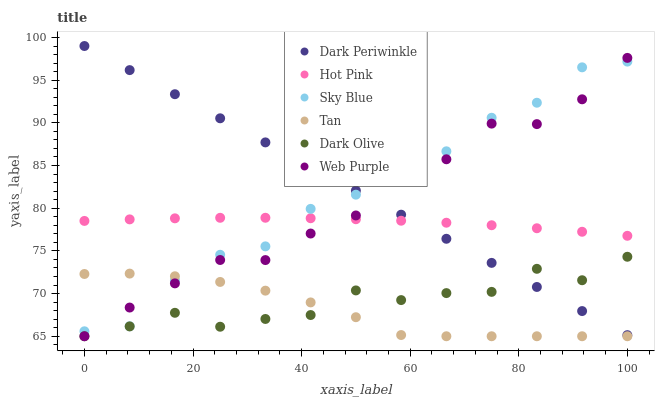Does Tan have the minimum area under the curve?
Answer yes or no. Yes. Does Dark Periwinkle have the maximum area under the curve?
Answer yes or no. Yes. Does Dark Olive have the minimum area under the curve?
Answer yes or no. No. Does Dark Olive have the maximum area under the curve?
Answer yes or no. No. Is Dark Periwinkle the smoothest?
Answer yes or no. Yes. Is Dark Olive the roughest?
Answer yes or no. Yes. Is Web Purple the smoothest?
Answer yes or no. No. Is Web Purple the roughest?
Answer yes or no. No. Does Dark Olive have the lowest value?
Answer yes or no. Yes. Does Sky Blue have the lowest value?
Answer yes or no. No. Does Dark Periwinkle have the highest value?
Answer yes or no. Yes. Does Dark Olive have the highest value?
Answer yes or no. No. Is Dark Olive less than Hot Pink?
Answer yes or no. Yes. Is Hot Pink greater than Dark Olive?
Answer yes or no. Yes. Does Tan intersect Web Purple?
Answer yes or no. Yes. Is Tan less than Web Purple?
Answer yes or no. No. Is Tan greater than Web Purple?
Answer yes or no. No. Does Dark Olive intersect Hot Pink?
Answer yes or no. No. 